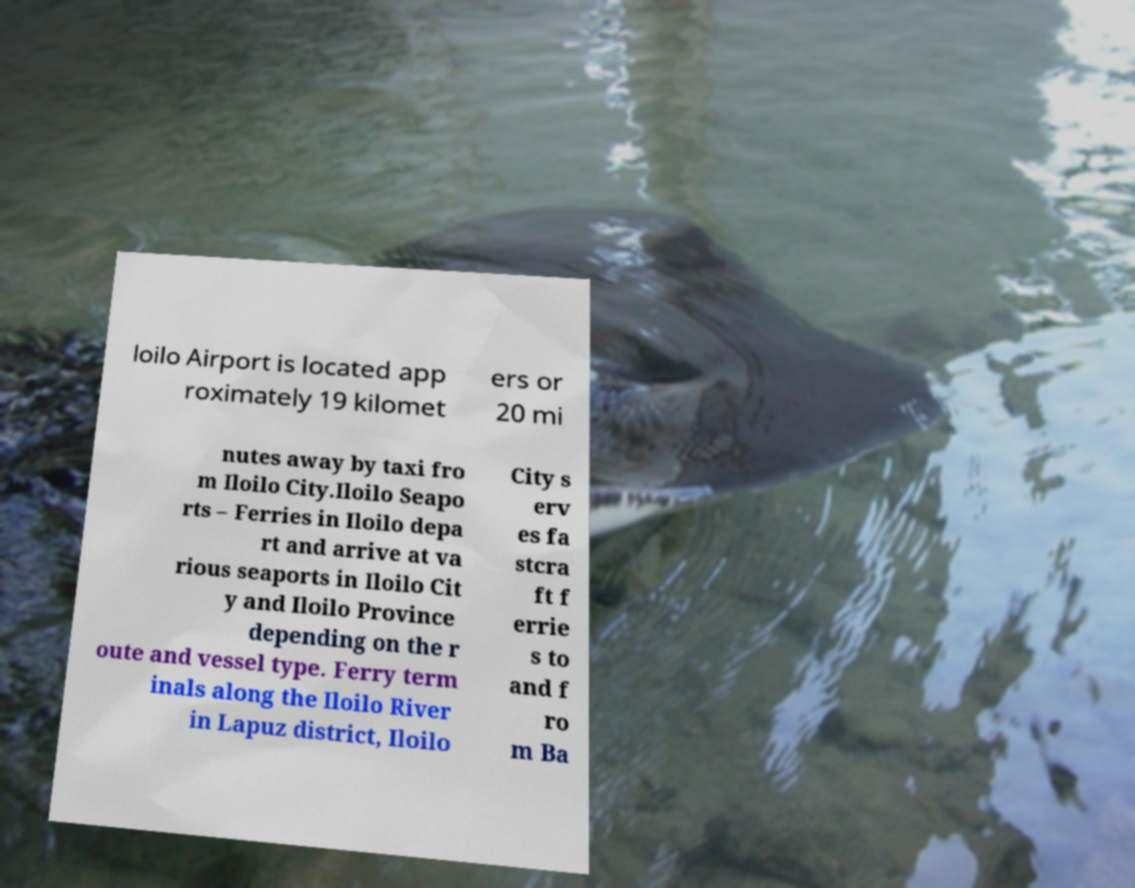Please identify and transcribe the text found in this image. loilo Airport is located app roximately 19 kilomet ers or 20 mi nutes away by taxi fro m Iloilo City.Iloilo Seapo rts – Ferries in Iloilo depa rt and arrive at va rious seaports in Iloilo Cit y and Iloilo Province depending on the r oute and vessel type. Ferry term inals along the Iloilo River in Lapuz district, Iloilo City s erv es fa stcra ft f errie s to and f ro m Ba 